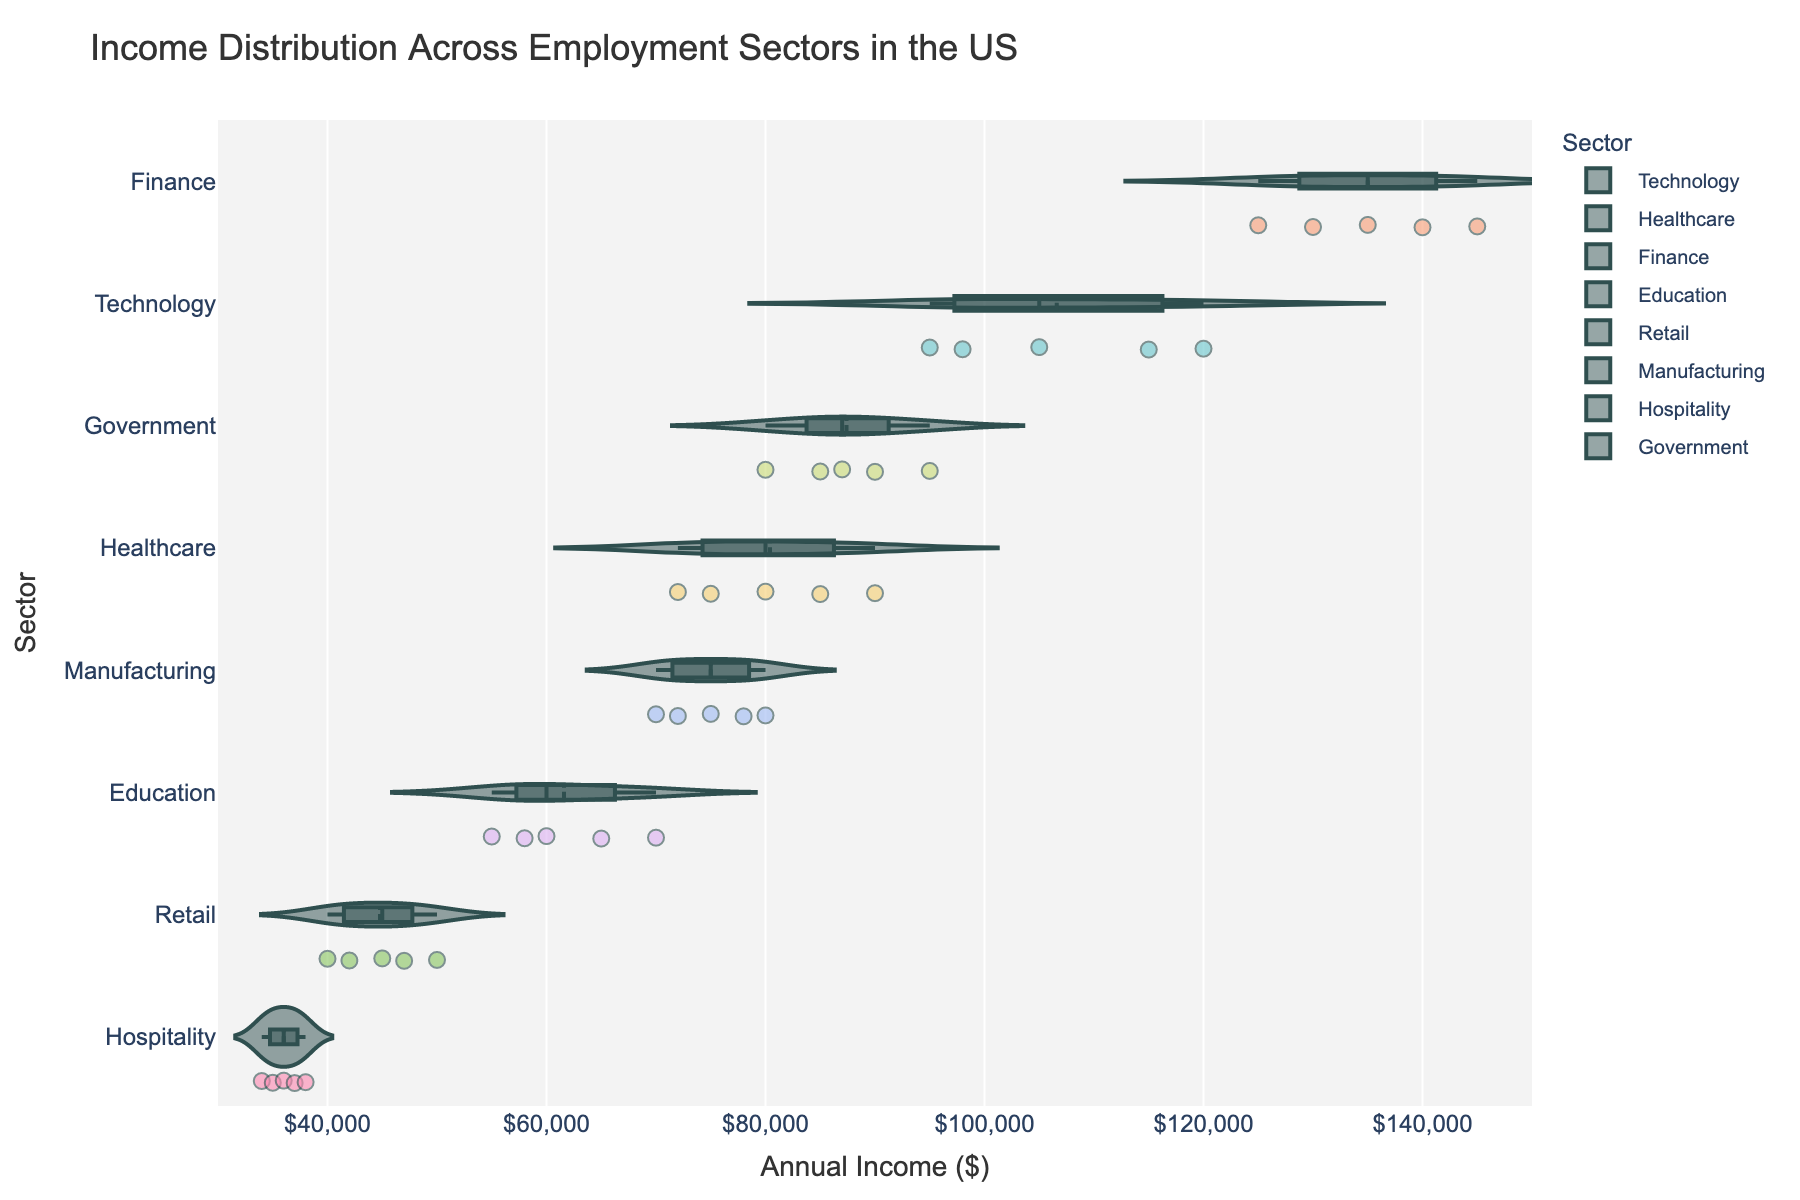How many employment sectors are represented in the chart? The y-axis of the chart lists different employment sectors. By counting the unique labels, we determine the total number of sectors.
Answer: 7 Which employment sector has the highest median income? To find the sector with the highest median income, examine the horizontal line inside the boxes of each violin plot. The sector where this line is the farthest to the right has the highest median income.
Answer: Finance What is the range of incomes within the Healthcare sector? The range is determined by the minimum and maximum points in the Healthcare sector's violin plot. The lowest individual point marks the minimum, and the highest point marks the maximum.
Answer: $72,000 to $90,000 Which sector shows the widest income distribution? The width of the distribution can be observed by looking at how spread out the violin shapes are horizontally. The sector with the most spread-out shape has the widest distribution.
Answer: Finance How does the mean income in Healthcare compare to that in Education? The mean is indicated by a line within each violin plot. Locate the lines for Healthcare and Education; comparing their positions horizontally shows the difference in mean incomes.
Answer: Higher in Healthcare Which sector has the smallest variability in incomes? Variability can be observed by the narrowness of the violin plot. The sector with the most condensed shape (least spread horizontally) indicates the smallest variability.
Answer: Hospitality In which sector do you see the highest number of data points? The density of the scatter points within each violin plot indicates the number of data points. The sector with the highest point concentration represents the highest number of data points.
Answer: Retail Between Technology and Government, which sector shows a higher lower quartile income? The lower quartile is indicated by the bottom edge of the box in each violin plot. Compare the positions of the lower edges for Technology and Government.
Answer: Government What can you infer about the income variability in Retail compared to Hospitality? By comparing the width of the violin plots for Retail and Hospitality, it's clear that a wider plot signifies greater variability.
Answer: More variable in Retail 